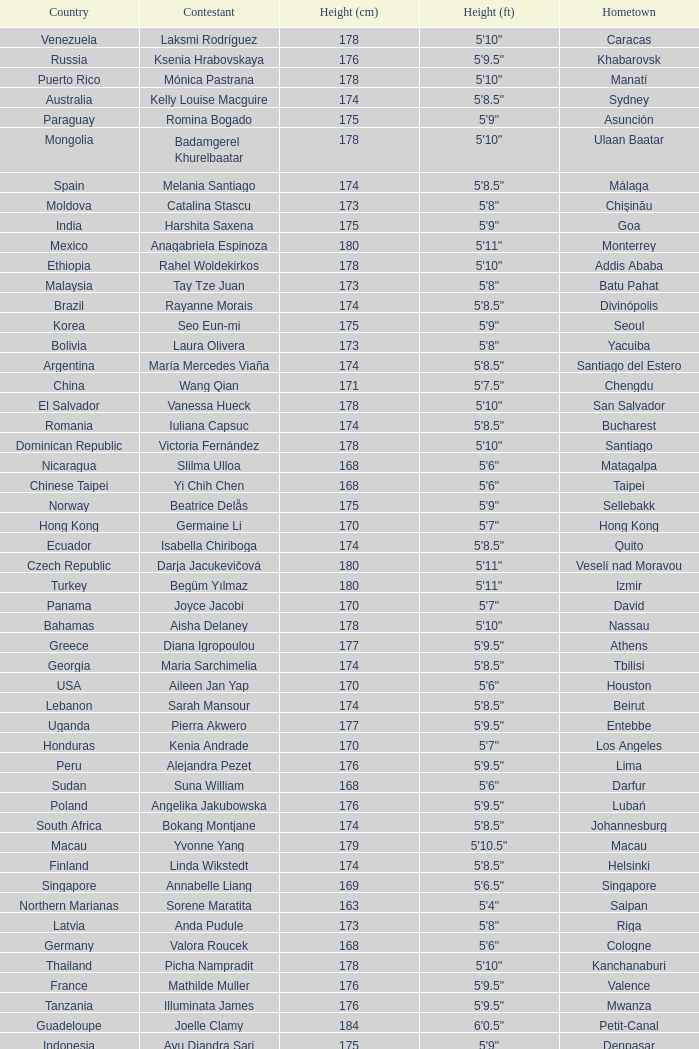What is the hometown of the player from Indonesia? Denpasar. 